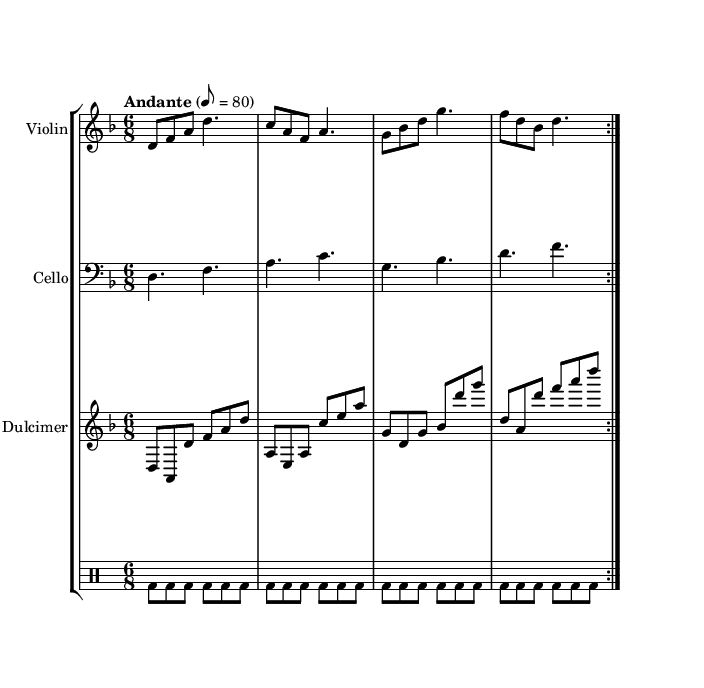What is the key signature of this music? The key signature is D minor, which has one flat (B flat).
Answer: D minor What is the time signature of the piece? The time signature is 6/8, indicating there are six eighth notes per measure.
Answer: 6/8 What is the tempo marking indicated in the score? The tempo marking is "Andante" with a metronome marking of 8 = 80, suggesting a moderately slow pace.
Answer: Andante How many times is the violin section repeated? The violin section is repeated two times as indicated by the "repeat volta 2" directive.
Answer: 2 What instrument plays the bass clef? The cello plays in the bass clef as indicated by the staff notated with a bass clef symbol.
Answer: Cello What rhythmic pattern is used in the dulcimer music? The dulcimer music features eighth notes followed by a pattern that creates a continuous flow in line with agricultural rhythms.
Answer: Eighth notes What role does the drum voice play in this composition? The drum voice provides a steady rhythmic foundation that complements the melodic lines, echoing the repetitive nature of agricultural work cycles.
Answer: Steady rhythmic foundation 